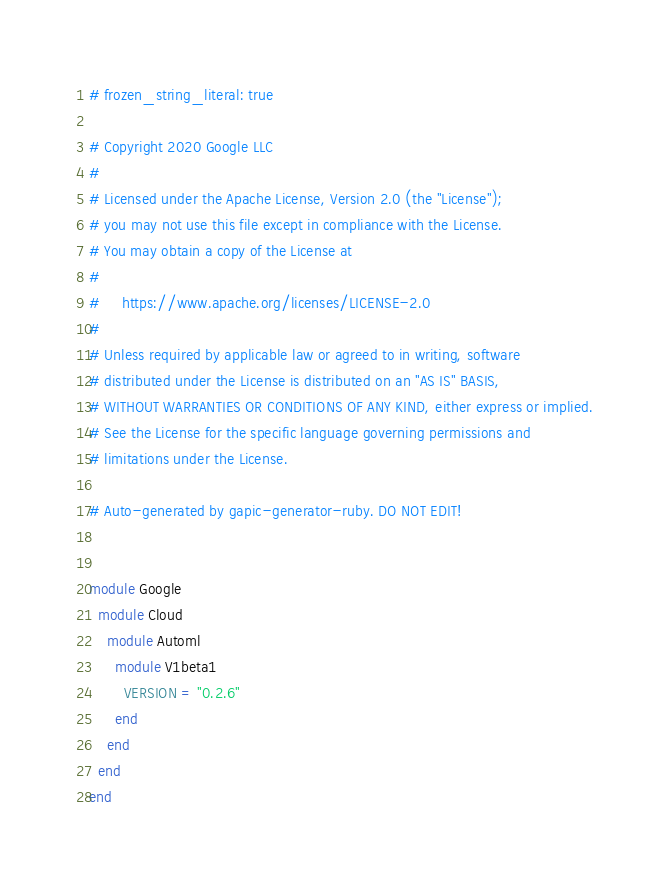<code> <loc_0><loc_0><loc_500><loc_500><_Ruby_># frozen_string_literal: true

# Copyright 2020 Google LLC
#
# Licensed under the Apache License, Version 2.0 (the "License");
# you may not use this file except in compliance with the License.
# You may obtain a copy of the License at
#
#     https://www.apache.org/licenses/LICENSE-2.0
#
# Unless required by applicable law or agreed to in writing, software
# distributed under the License is distributed on an "AS IS" BASIS,
# WITHOUT WARRANTIES OR CONDITIONS OF ANY KIND, either express or implied.
# See the License for the specific language governing permissions and
# limitations under the License.

# Auto-generated by gapic-generator-ruby. DO NOT EDIT!


module Google
  module Cloud
    module Automl
      module V1beta1
        VERSION = "0.2.6"
      end
    end
  end
end
</code> 